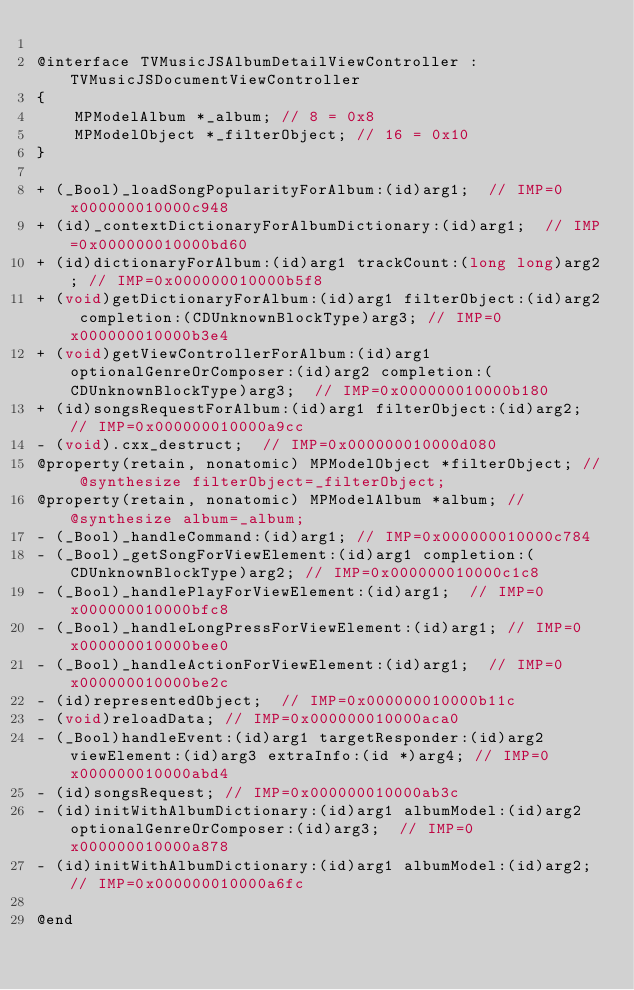<code> <loc_0><loc_0><loc_500><loc_500><_C_>
@interface TVMusicJSAlbumDetailViewController : TVMusicJSDocumentViewController
{
    MPModelAlbum *_album;	// 8 = 0x8
    MPModelObject *_filterObject;	// 16 = 0x10
}

+ (_Bool)_loadSongPopularityForAlbum:(id)arg1;	// IMP=0x000000010000c948
+ (id)_contextDictionaryForAlbumDictionary:(id)arg1;	// IMP=0x000000010000bd60
+ (id)dictionaryForAlbum:(id)arg1 trackCount:(long long)arg2;	// IMP=0x000000010000b5f8
+ (void)getDictionaryForAlbum:(id)arg1 filterObject:(id)arg2 completion:(CDUnknownBlockType)arg3;	// IMP=0x000000010000b3e4
+ (void)getViewControllerForAlbum:(id)arg1 optionalGenreOrComposer:(id)arg2 completion:(CDUnknownBlockType)arg3;	// IMP=0x000000010000b180
+ (id)songsRequestForAlbum:(id)arg1 filterObject:(id)arg2;	// IMP=0x000000010000a9cc
- (void).cxx_destruct;	// IMP=0x000000010000d080
@property(retain, nonatomic) MPModelObject *filterObject; // @synthesize filterObject=_filterObject;
@property(retain, nonatomic) MPModelAlbum *album; // @synthesize album=_album;
- (_Bool)_handleCommand:(id)arg1;	// IMP=0x000000010000c784
- (_Bool)_getSongForViewElement:(id)arg1 completion:(CDUnknownBlockType)arg2;	// IMP=0x000000010000c1c8
- (_Bool)_handlePlayForViewElement:(id)arg1;	// IMP=0x000000010000bfc8
- (_Bool)_handleLongPressForViewElement:(id)arg1;	// IMP=0x000000010000bee0
- (_Bool)_handleActionForViewElement:(id)arg1;	// IMP=0x000000010000be2c
- (id)representedObject;	// IMP=0x000000010000b11c
- (void)reloadData;	// IMP=0x000000010000aca0
- (_Bool)handleEvent:(id)arg1 targetResponder:(id)arg2 viewElement:(id)arg3 extraInfo:(id *)arg4;	// IMP=0x000000010000abd4
- (id)songsRequest;	// IMP=0x000000010000ab3c
- (id)initWithAlbumDictionary:(id)arg1 albumModel:(id)arg2 optionalGenreOrComposer:(id)arg3;	// IMP=0x000000010000a878
- (id)initWithAlbumDictionary:(id)arg1 albumModel:(id)arg2;	// IMP=0x000000010000a6fc

@end

</code> 